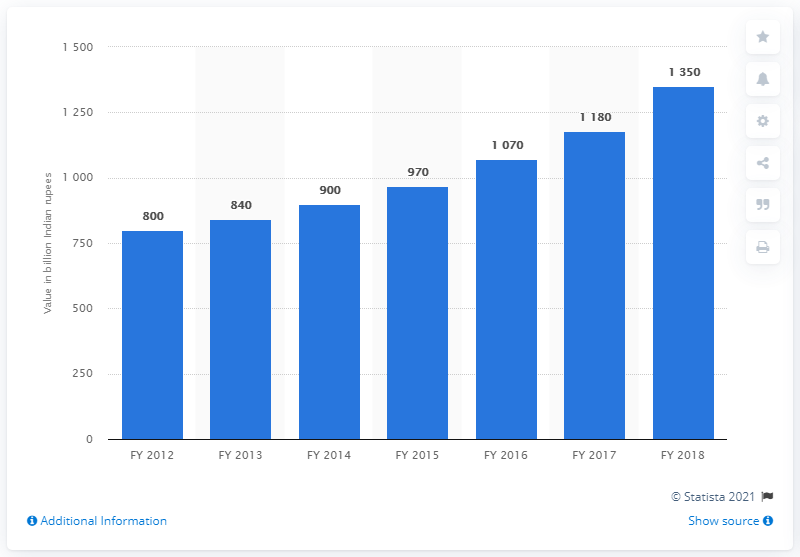Highlight a few significant elements in this photo. The increase in value in billion Indian rupees in FY 2015 from FY 2014 was 70. In FY 2015, the gross value was calculated to be 970. 